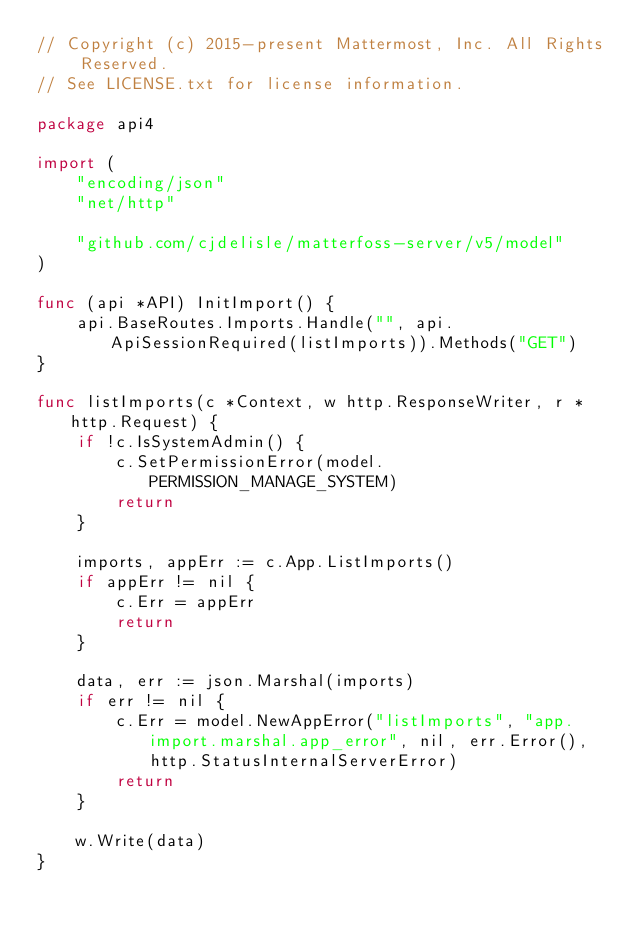<code> <loc_0><loc_0><loc_500><loc_500><_Go_>// Copyright (c) 2015-present Mattermost, Inc. All Rights Reserved.
// See LICENSE.txt for license information.

package api4

import (
	"encoding/json"
	"net/http"

	"github.com/cjdelisle/matterfoss-server/v5/model"
)

func (api *API) InitImport() {
	api.BaseRoutes.Imports.Handle("", api.ApiSessionRequired(listImports)).Methods("GET")
}

func listImports(c *Context, w http.ResponseWriter, r *http.Request) {
	if !c.IsSystemAdmin() {
		c.SetPermissionError(model.PERMISSION_MANAGE_SYSTEM)
		return
	}

	imports, appErr := c.App.ListImports()
	if appErr != nil {
		c.Err = appErr
		return
	}

	data, err := json.Marshal(imports)
	if err != nil {
		c.Err = model.NewAppError("listImports", "app.import.marshal.app_error", nil, err.Error(), http.StatusInternalServerError)
		return
	}

	w.Write(data)
}
</code> 